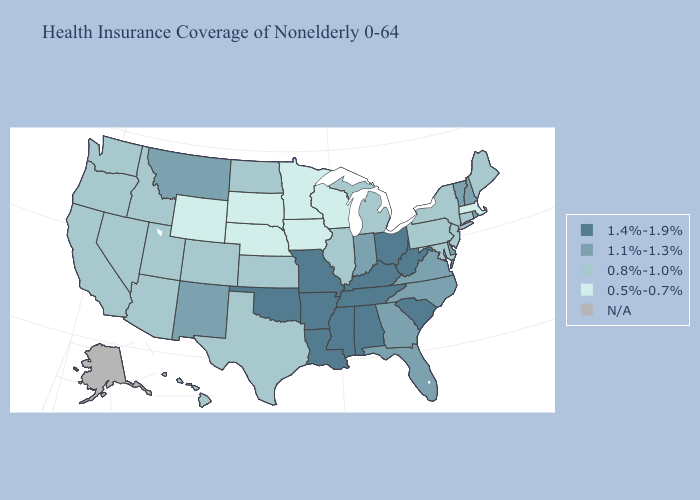What is the lowest value in states that border Virginia?
Short answer required. 0.8%-1.0%. Which states have the lowest value in the South?
Be succinct. Maryland, Texas. Name the states that have a value in the range 1.1%-1.3%?
Write a very short answer. Delaware, Florida, Georgia, Indiana, Montana, New Hampshire, New Mexico, North Carolina, Rhode Island, Vermont, Virginia. Which states hav the highest value in the South?
Keep it brief. Alabama, Arkansas, Kentucky, Louisiana, Mississippi, Oklahoma, South Carolina, Tennessee, West Virginia. Is the legend a continuous bar?
Give a very brief answer. No. Name the states that have a value in the range N/A?
Quick response, please. Alaska. Among the states that border Kentucky , does Illinois have the highest value?
Keep it brief. No. Among the states that border Arkansas , which have the lowest value?
Be succinct. Texas. Among the states that border New Jersey , does Delaware have the lowest value?
Be succinct. No. What is the highest value in states that border South Dakota?
Give a very brief answer. 1.1%-1.3%. Does New Hampshire have the highest value in the Northeast?
Short answer required. Yes. What is the lowest value in the West?
Be succinct. 0.5%-0.7%. Name the states that have a value in the range 0.5%-0.7%?
Keep it brief. Iowa, Massachusetts, Minnesota, Nebraska, South Dakota, Wisconsin, Wyoming. Name the states that have a value in the range 1.4%-1.9%?
Write a very short answer. Alabama, Arkansas, Kentucky, Louisiana, Mississippi, Missouri, Ohio, Oklahoma, South Carolina, Tennessee, West Virginia. 